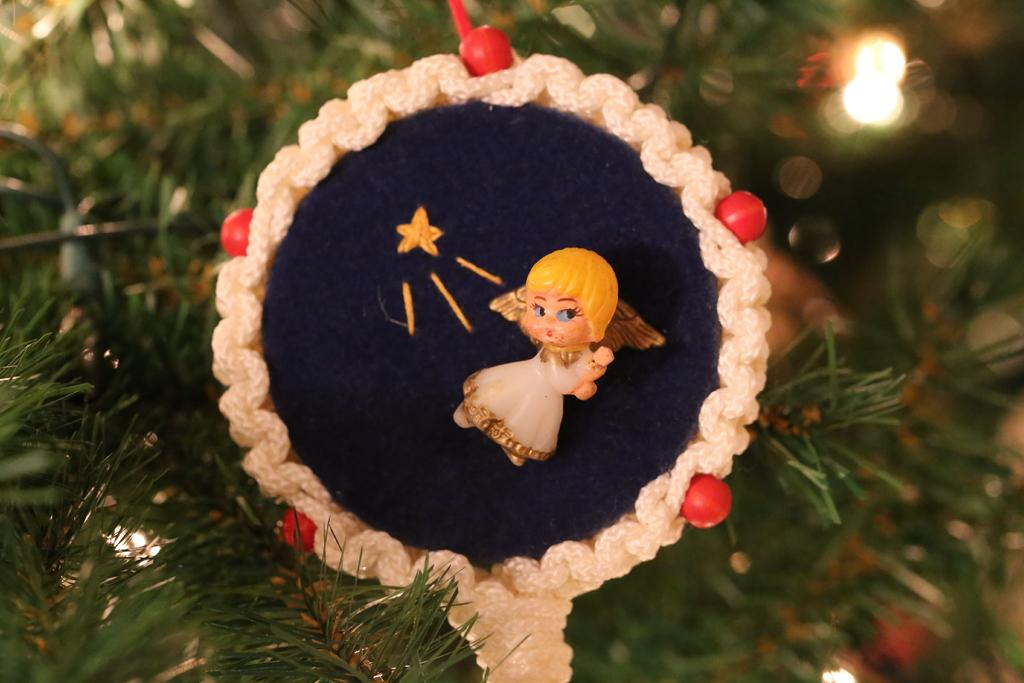What is the main subject of the image? There is a Christmas tree in the image. Where is the Christmas tree located in the image? The Christmas tree is in the middle of the image. What can be seen on the Christmas tree? There are decorative items on the tree. Can you describe one of the decorative items on the tree? There is a small doll on one of the decorative items. What type of shoes are hanging on the Christmas tree in the image? There are no shoes present on the Christmas tree in the image. 